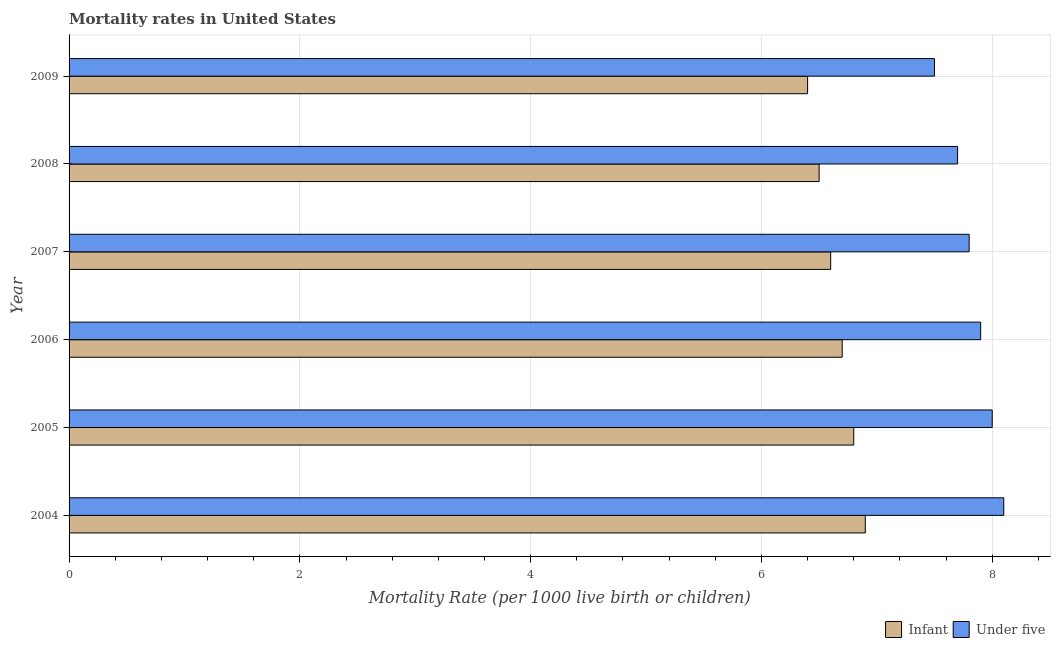Are the number of bars per tick equal to the number of legend labels?
Offer a very short reply. Yes. Are the number of bars on each tick of the Y-axis equal?
Give a very brief answer. Yes. How many bars are there on the 5th tick from the top?
Your answer should be very brief. 2. How many bars are there on the 1st tick from the bottom?
Provide a short and direct response. 2. What is the infant mortality rate in 2005?
Keep it short and to the point. 6.8. Across all years, what is the maximum under-5 mortality rate?
Offer a very short reply. 8.1. What is the total infant mortality rate in the graph?
Offer a very short reply. 39.9. What is the difference between the infant mortality rate in 2006 and that in 2008?
Give a very brief answer. 0.2. What is the difference between the infant mortality rate in 2006 and the under-5 mortality rate in 2005?
Your answer should be compact. -1.3. What is the average infant mortality rate per year?
Make the answer very short. 6.65. What is the ratio of the infant mortality rate in 2006 to that in 2009?
Keep it short and to the point. 1.05. What is the difference between the highest and the second highest infant mortality rate?
Offer a very short reply. 0.1. What is the difference between the highest and the lowest infant mortality rate?
Ensure brevity in your answer.  0.5. What does the 2nd bar from the top in 2005 represents?
Offer a terse response. Infant. What does the 2nd bar from the bottom in 2008 represents?
Your answer should be very brief. Under five. How many bars are there?
Ensure brevity in your answer.  12. Are all the bars in the graph horizontal?
Your answer should be very brief. Yes. What is the difference between two consecutive major ticks on the X-axis?
Ensure brevity in your answer.  2. Are the values on the major ticks of X-axis written in scientific E-notation?
Keep it short and to the point. No. Where does the legend appear in the graph?
Keep it short and to the point. Bottom right. What is the title of the graph?
Your answer should be compact. Mortality rates in United States. Does "DAC donors" appear as one of the legend labels in the graph?
Your answer should be very brief. No. What is the label or title of the X-axis?
Offer a terse response. Mortality Rate (per 1000 live birth or children). What is the Mortality Rate (per 1000 live birth or children) of Infant in 2004?
Offer a terse response. 6.9. What is the Mortality Rate (per 1000 live birth or children) in Under five in 2004?
Offer a terse response. 8.1. What is the Mortality Rate (per 1000 live birth or children) of Under five in 2005?
Your answer should be compact. 8. What is the Mortality Rate (per 1000 live birth or children) of Under five in 2006?
Ensure brevity in your answer.  7.9. What is the Mortality Rate (per 1000 live birth or children) in Under five in 2007?
Make the answer very short. 7.8. What is the Mortality Rate (per 1000 live birth or children) in Infant in 2008?
Your answer should be compact. 6.5. What is the Mortality Rate (per 1000 live birth or children) in Under five in 2008?
Your answer should be very brief. 7.7. What is the Mortality Rate (per 1000 live birth or children) of Infant in 2009?
Provide a short and direct response. 6.4. Across all years, what is the maximum Mortality Rate (per 1000 live birth or children) in Infant?
Your answer should be compact. 6.9. What is the total Mortality Rate (per 1000 live birth or children) of Infant in the graph?
Make the answer very short. 39.9. What is the total Mortality Rate (per 1000 live birth or children) in Under five in the graph?
Provide a short and direct response. 47. What is the difference between the Mortality Rate (per 1000 live birth or children) in Under five in 2004 and that in 2006?
Provide a short and direct response. 0.2. What is the difference between the Mortality Rate (per 1000 live birth or children) of Under five in 2004 and that in 2007?
Keep it short and to the point. 0.3. What is the difference between the Mortality Rate (per 1000 live birth or children) in Infant in 2004 and that in 2008?
Ensure brevity in your answer.  0.4. What is the difference between the Mortality Rate (per 1000 live birth or children) of Under five in 2004 and that in 2008?
Ensure brevity in your answer.  0.4. What is the difference between the Mortality Rate (per 1000 live birth or children) of Infant in 2005 and that in 2007?
Your answer should be very brief. 0.2. What is the difference between the Mortality Rate (per 1000 live birth or children) in Under five in 2005 and that in 2007?
Offer a terse response. 0.2. What is the difference between the Mortality Rate (per 1000 live birth or children) in Infant in 2005 and that in 2008?
Ensure brevity in your answer.  0.3. What is the difference between the Mortality Rate (per 1000 live birth or children) of Under five in 2005 and that in 2008?
Your answer should be very brief. 0.3. What is the difference between the Mortality Rate (per 1000 live birth or children) of Infant in 2005 and that in 2009?
Give a very brief answer. 0.4. What is the difference between the Mortality Rate (per 1000 live birth or children) in Infant in 2006 and that in 2007?
Provide a succinct answer. 0.1. What is the difference between the Mortality Rate (per 1000 live birth or children) in Infant in 2006 and that in 2008?
Provide a succinct answer. 0.2. What is the difference between the Mortality Rate (per 1000 live birth or children) in Under five in 2006 and that in 2008?
Your answer should be very brief. 0.2. What is the difference between the Mortality Rate (per 1000 live birth or children) in Infant in 2006 and that in 2009?
Your response must be concise. 0.3. What is the difference between the Mortality Rate (per 1000 live birth or children) of Infant in 2007 and that in 2008?
Your answer should be compact. 0.1. What is the difference between the Mortality Rate (per 1000 live birth or children) of Infant in 2007 and that in 2009?
Ensure brevity in your answer.  0.2. What is the difference between the Mortality Rate (per 1000 live birth or children) in Infant in 2004 and the Mortality Rate (per 1000 live birth or children) in Under five in 2007?
Ensure brevity in your answer.  -0.9. What is the difference between the Mortality Rate (per 1000 live birth or children) of Infant in 2004 and the Mortality Rate (per 1000 live birth or children) of Under five in 2009?
Keep it short and to the point. -0.6. What is the difference between the Mortality Rate (per 1000 live birth or children) of Infant in 2005 and the Mortality Rate (per 1000 live birth or children) of Under five in 2009?
Provide a succinct answer. -0.7. What is the difference between the Mortality Rate (per 1000 live birth or children) of Infant in 2006 and the Mortality Rate (per 1000 live birth or children) of Under five in 2008?
Your response must be concise. -1. What is the difference between the Mortality Rate (per 1000 live birth or children) in Infant in 2006 and the Mortality Rate (per 1000 live birth or children) in Under five in 2009?
Keep it short and to the point. -0.8. What is the difference between the Mortality Rate (per 1000 live birth or children) of Infant in 2007 and the Mortality Rate (per 1000 live birth or children) of Under five in 2008?
Offer a very short reply. -1.1. What is the difference between the Mortality Rate (per 1000 live birth or children) of Infant in 2008 and the Mortality Rate (per 1000 live birth or children) of Under five in 2009?
Offer a terse response. -1. What is the average Mortality Rate (per 1000 live birth or children) of Infant per year?
Your answer should be very brief. 6.65. What is the average Mortality Rate (per 1000 live birth or children) in Under five per year?
Your answer should be compact. 7.83. In the year 2004, what is the difference between the Mortality Rate (per 1000 live birth or children) of Infant and Mortality Rate (per 1000 live birth or children) of Under five?
Your answer should be compact. -1.2. In the year 2007, what is the difference between the Mortality Rate (per 1000 live birth or children) in Infant and Mortality Rate (per 1000 live birth or children) in Under five?
Ensure brevity in your answer.  -1.2. What is the ratio of the Mortality Rate (per 1000 live birth or children) of Infant in 2004 to that in 2005?
Keep it short and to the point. 1.01. What is the ratio of the Mortality Rate (per 1000 live birth or children) in Under five in 2004 to that in 2005?
Make the answer very short. 1.01. What is the ratio of the Mortality Rate (per 1000 live birth or children) in Infant in 2004 to that in 2006?
Your answer should be very brief. 1.03. What is the ratio of the Mortality Rate (per 1000 live birth or children) in Under five in 2004 to that in 2006?
Ensure brevity in your answer.  1.03. What is the ratio of the Mortality Rate (per 1000 live birth or children) in Infant in 2004 to that in 2007?
Provide a succinct answer. 1.05. What is the ratio of the Mortality Rate (per 1000 live birth or children) in Under five in 2004 to that in 2007?
Provide a short and direct response. 1.04. What is the ratio of the Mortality Rate (per 1000 live birth or children) of Infant in 2004 to that in 2008?
Provide a succinct answer. 1.06. What is the ratio of the Mortality Rate (per 1000 live birth or children) of Under five in 2004 to that in 2008?
Provide a short and direct response. 1.05. What is the ratio of the Mortality Rate (per 1000 live birth or children) of Infant in 2004 to that in 2009?
Your response must be concise. 1.08. What is the ratio of the Mortality Rate (per 1000 live birth or children) of Infant in 2005 to that in 2006?
Keep it short and to the point. 1.01. What is the ratio of the Mortality Rate (per 1000 live birth or children) in Under five in 2005 to that in 2006?
Your answer should be compact. 1.01. What is the ratio of the Mortality Rate (per 1000 live birth or children) of Infant in 2005 to that in 2007?
Your answer should be compact. 1.03. What is the ratio of the Mortality Rate (per 1000 live birth or children) in Under five in 2005 to that in 2007?
Make the answer very short. 1.03. What is the ratio of the Mortality Rate (per 1000 live birth or children) of Infant in 2005 to that in 2008?
Your response must be concise. 1.05. What is the ratio of the Mortality Rate (per 1000 live birth or children) of Under five in 2005 to that in 2008?
Your response must be concise. 1.04. What is the ratio of the Mortality Rate (per 1000 live birth or children) of Infant in 2005 to that in 2009?
Ensure brevity in your answer.  1.06. What is the ratio of the Mortality Rate (per 1000 live birth or children) of Under five in 2005 to that in 2009?
Provide a succinct answer. 1.07. What is the ratio of the Mortality Rate (per 1000 live birth or children) in Infant in 2006 to that in 2007?
Ensure brevity in your answer.  1.02. What is the ratio of the Mortality Rate (per 1000 live birth or children) of Under five in 2006 to that in 2007?
Your answer should be compact. 1.01. What is the ratio of the Mortality Rate (per 1000 live birth or children) in Infant in 2006 to that in 2008?
Provide a short and direct response. 1.03. What is the ratio of the Mortality Rate (per 1000 live birth or children) of Infant in 2006 to that in 2009?
Offer a terse response. 1.05. What is the ratio of the Mortality Rate (per 1000 live birth or children) in Under five in 2006 to that in 2009?
Offer a terse response. 1.05. What is the ratio of the Mortality Rate (per 1000 live birth or children) of Infant in 2007 to that in 2008?
Ensure brevity in your answer.  1.02. What is the ratio of the Mortality Rate (per 1000 live birth or children) in Infant in 2007 to that in 2009?
Your answer should be compact. 1.03. What is the ratio of the Mortality Rate (per 1000 live birth or children) in Infant in 2008 to that in 2009?
Offer a terse response. 1.02. What is the ratio of the Mortality Rate (per 1000 live birth or children) of Under five in 2008 to that in 2009?
Your response must be concise. 1.03. What is the difference between the highest and the second highest Mortality Rate (per 1000 live birth or children) in Under five?
Give a very brief answer. 0.1. What is the difference between the highest and the lowest Mortality Rate (per 1000 live birth or children) in Infant?
Your answer should be very brief. 0.5. What is the difference between the highest and the lowest Mortality Rate (per 1000 live birth or children) of Under five?
Your answer should be very brief. 0.6. 